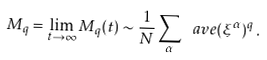Convert formula to latex. <formula><loc_0><loc_0><loc_500><loc_500>M _ { q } = \lim _ { t \to \infty } M _ { q } ( t ) \sim \frac { 1 } { N } \sum _ { \alpha } \ a v e { ( \xi ^ { \alpha } ) ^ { q } } \, .</formula> 